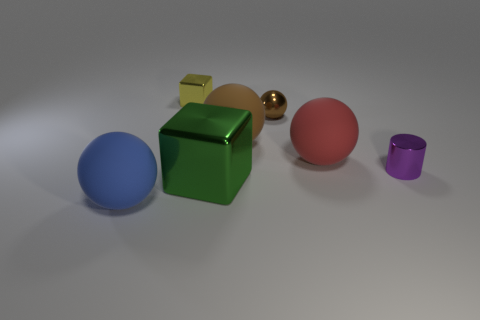Subtract all yellow balls. Subtract all red cylinders. How many balls are left? 4 Add 2 brown metal things. How many objects exist? 9 Subtract all blocks. How many objects are left? 5 Add 6 tiny purple metallic objects. How many tiny purple metallic objects exist? 7 Subtract 0 gray spheres. How many objects are left? 7 Subtract all shiny blocks. Subtract all red rubber spheres. How many objects are left? 4 Add 4 large blue spheres. How many large blue spheres are left? 5 